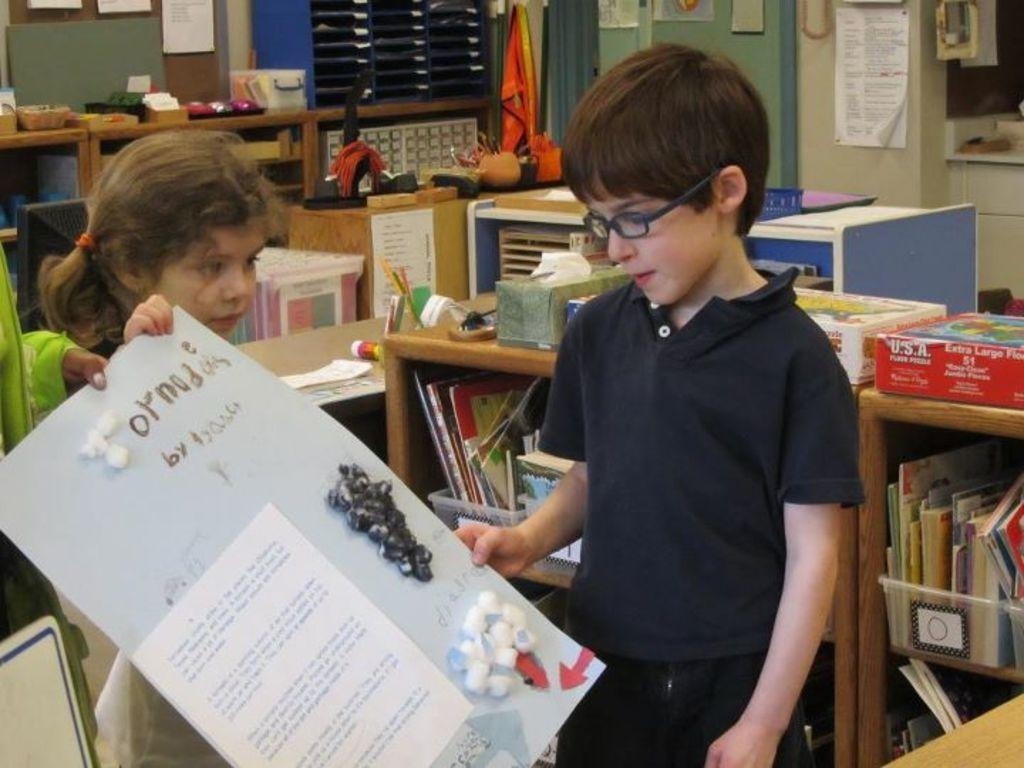Who are the people in the image? There is a small girl and a boy in the image. What is the boy holding? The boy is holding a poster. What can be seen in the background of the image? There are bookshelves, a desk, and other objects in the background of the image. Are there any other posters visible in the image? Yes, there are posters in the background of the image. Can you tell me how many birds are nesting in the elbow of the small girl in the image? There are no birds or elbows visible in the image, so it is not possible to answer that question. 